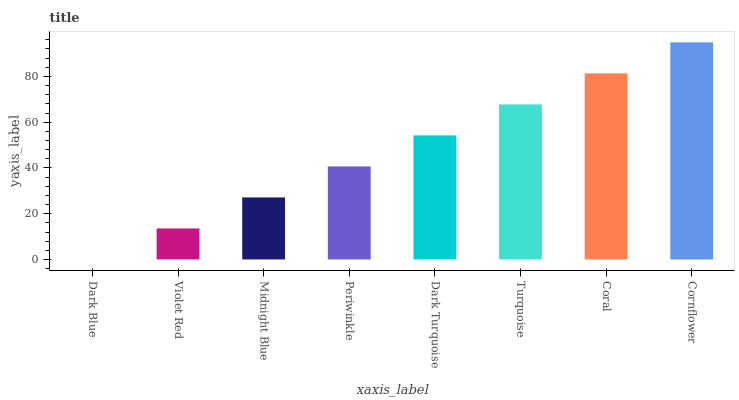Is Dark Blue the minimum?
Answer yes or no. Yes. Is Cornflower the maximum?
Answer yes or no. Yes. Is Violet Red the minimum?
Answer yes or no. No. Is Violet Red the maximum?
Answer yes or no. No. Is Violet Red greater than Dark Blue?
Answer yes or no. Yes. Is Dark Blue less than Violet Red?
Answer yes or no. Yes. Is Dark Blue greater than Violet Red?
Answer yes or no. No. Is Violet Red less than Dark Blue?
Answer yes or no. No. Is Dark Turquoise the high median?
Answer yes or no. Yes. Is Periwinkle the low median?
Answer yes or no. Yes. Is Dark Blue the high median?
Answer yes or no. No. Is Dark Blue the low median?
Answer yes or no. No. 